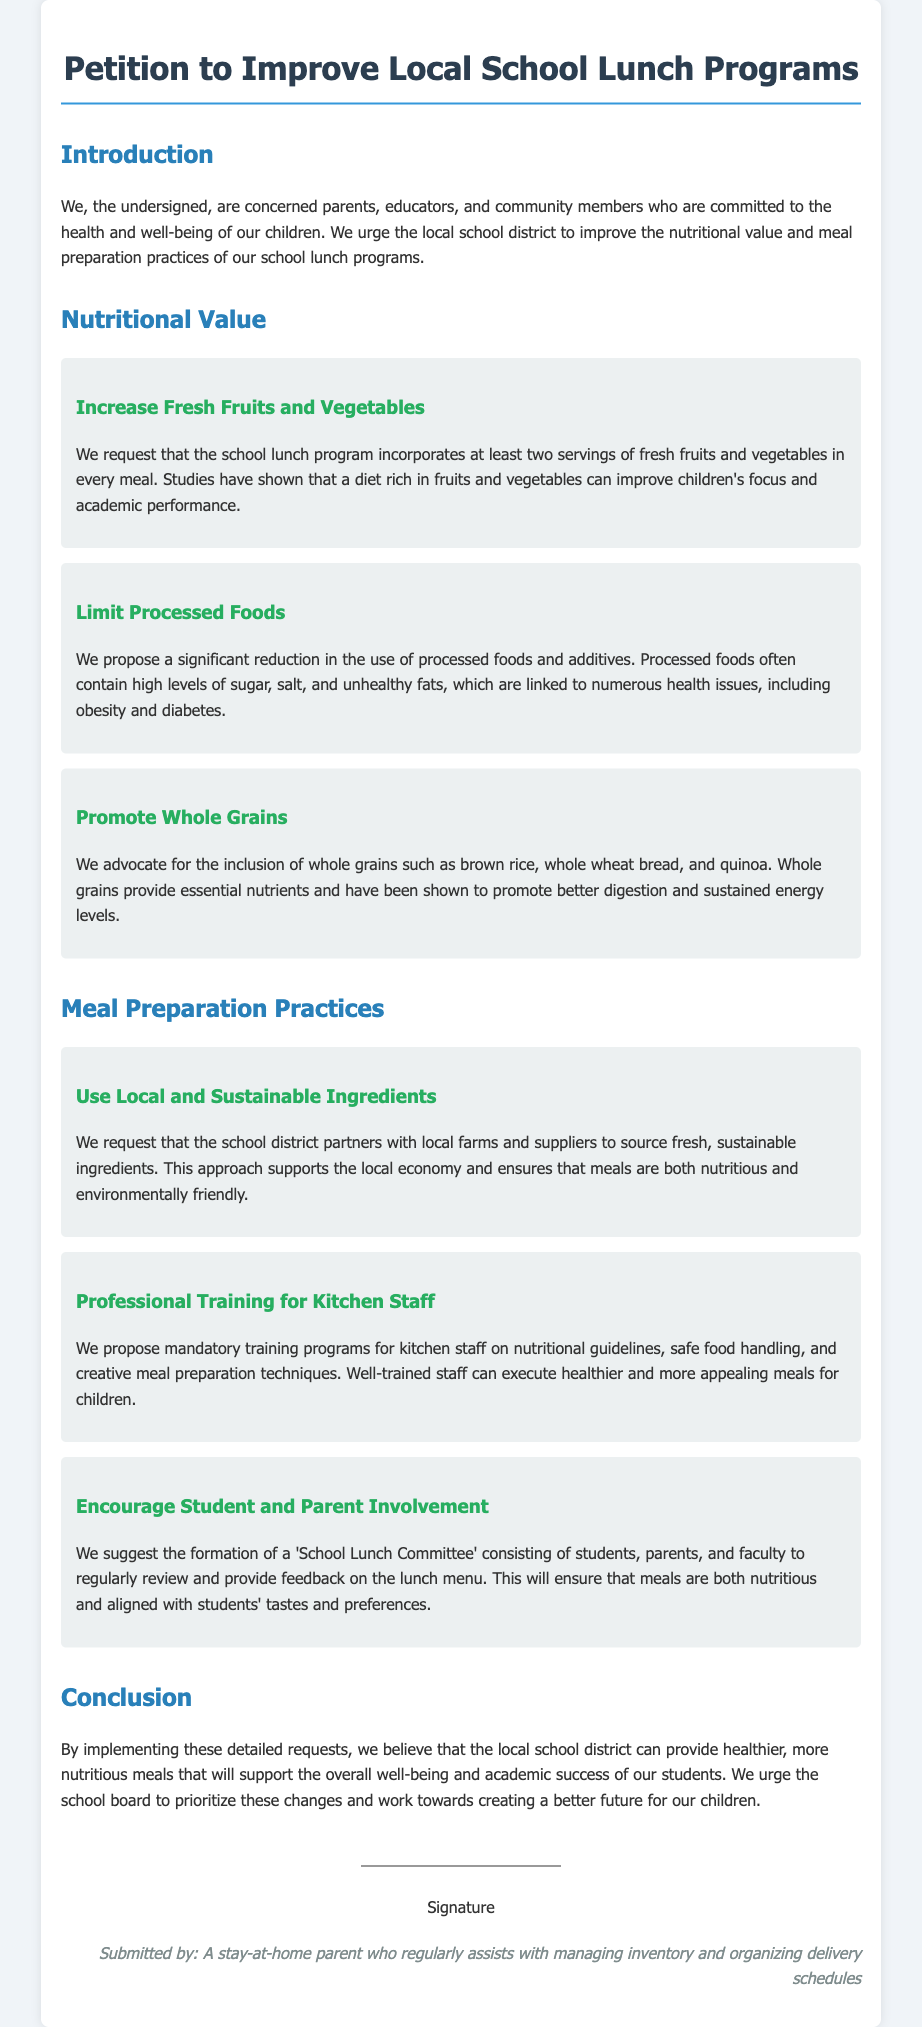What is the main purpose of the petition? The main purpose of the petition is to improve the nutritional value and meal preparation practices of school lunch programs.
Answer: Improve nutritional value and meal preparation practices How many servings of fresh fruits and vegetables are requested per meal? The document states that the petition requests at least two servings of fresh fruits and vegetables in every meal.
Answer: Two servings What type of grains does the petition advocate for? The petition advocates for the inclusion of whole grains such as brown rice, whole wheat bread, and quinoa.
Answer: Whole grains What is suggested to support the local economy? The document suggests partnering with local farms and suppliers to source fresh, sustainable ingredients.
Answer: Partnering with local farms Who is proposed to be included in the 'School Lunch Committee'? The committee is suggested to consist of students, parents, and faculty.
Answer: Students, parents, and faculty What training is proposed for kitchen staff? The document proposes mandatory training programs for kitchen staff on nutritional guidelines and safe food handling.
Answer: Mandatory training programs What issue is linked to processed foods according to the petition? The petition states that processed foods are linked to health issues, including obesity and diabetes.
Answer: Health issues, including obesity and diabetes What is the document type of this content? The format of the content is a petition.
Answer: Petition 